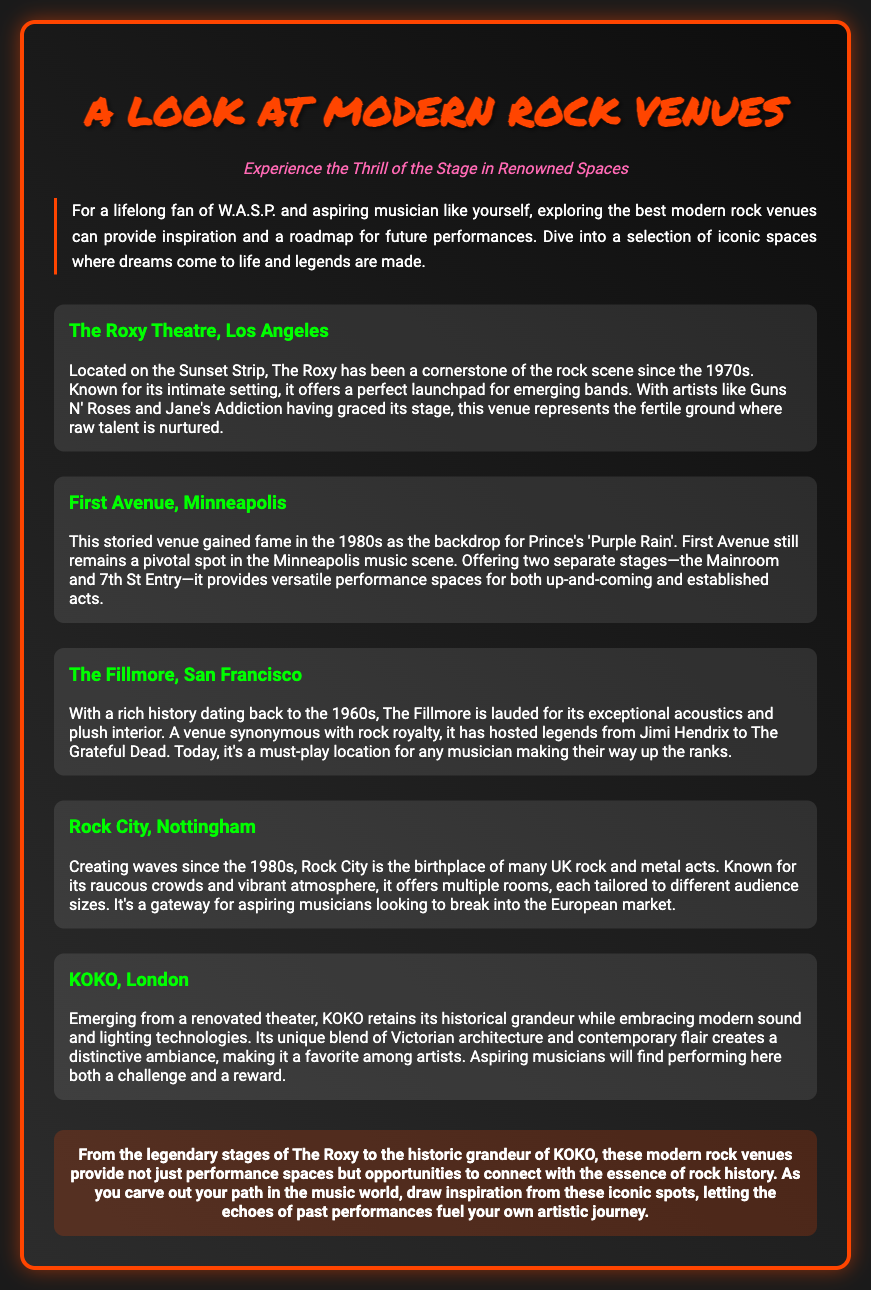What is the title of the Playbill? The title is prominently displayed at the top of the document, providing the main focus of the content.
Answer: A Look at Modern Rock Venues Which venue is located on the Sunset Strip? The Roxy Theatre is mentioned as being located on the Sunset Strip in Los Angeles, highlighting its iconic status.
Answer: The Roxy Theatre What year is The Fillmore's history noted to date back to? The document states that The Fillmore has a rich history dating back to the 1960s.
Answer: 1960s What is the unique feature of KOKO mentioned in the document? KOKO is noted for its unique blend of Victorian architecture and contemporary flair, creating a distinctive ambiance.
Answer: Victorian architecture and contemporary flair Which venue is well-known for its vibrant atmosphere and raucous crowds? Rock City is specifically described as a venue with a raucous crowd and vibrant atmosphere, catering to rock music.
Answer: Rock City What are the two stages at First Avenue? The document lists two separate stages at First Avenue, indicating its versatility as a performance space.
Answer: Mainroom and 7th St Entry Which artist is associated with First Avenue due to a famous film? Prince is mentioned in connection with First Avenue and the film 'Purple Rain', establishing its cultural significance.
Answer: Prince What color is the border of the Playbill? The description includes details about the playbill's aesthetics, specifically mentioning the border's color.
Answer: #ff4500 